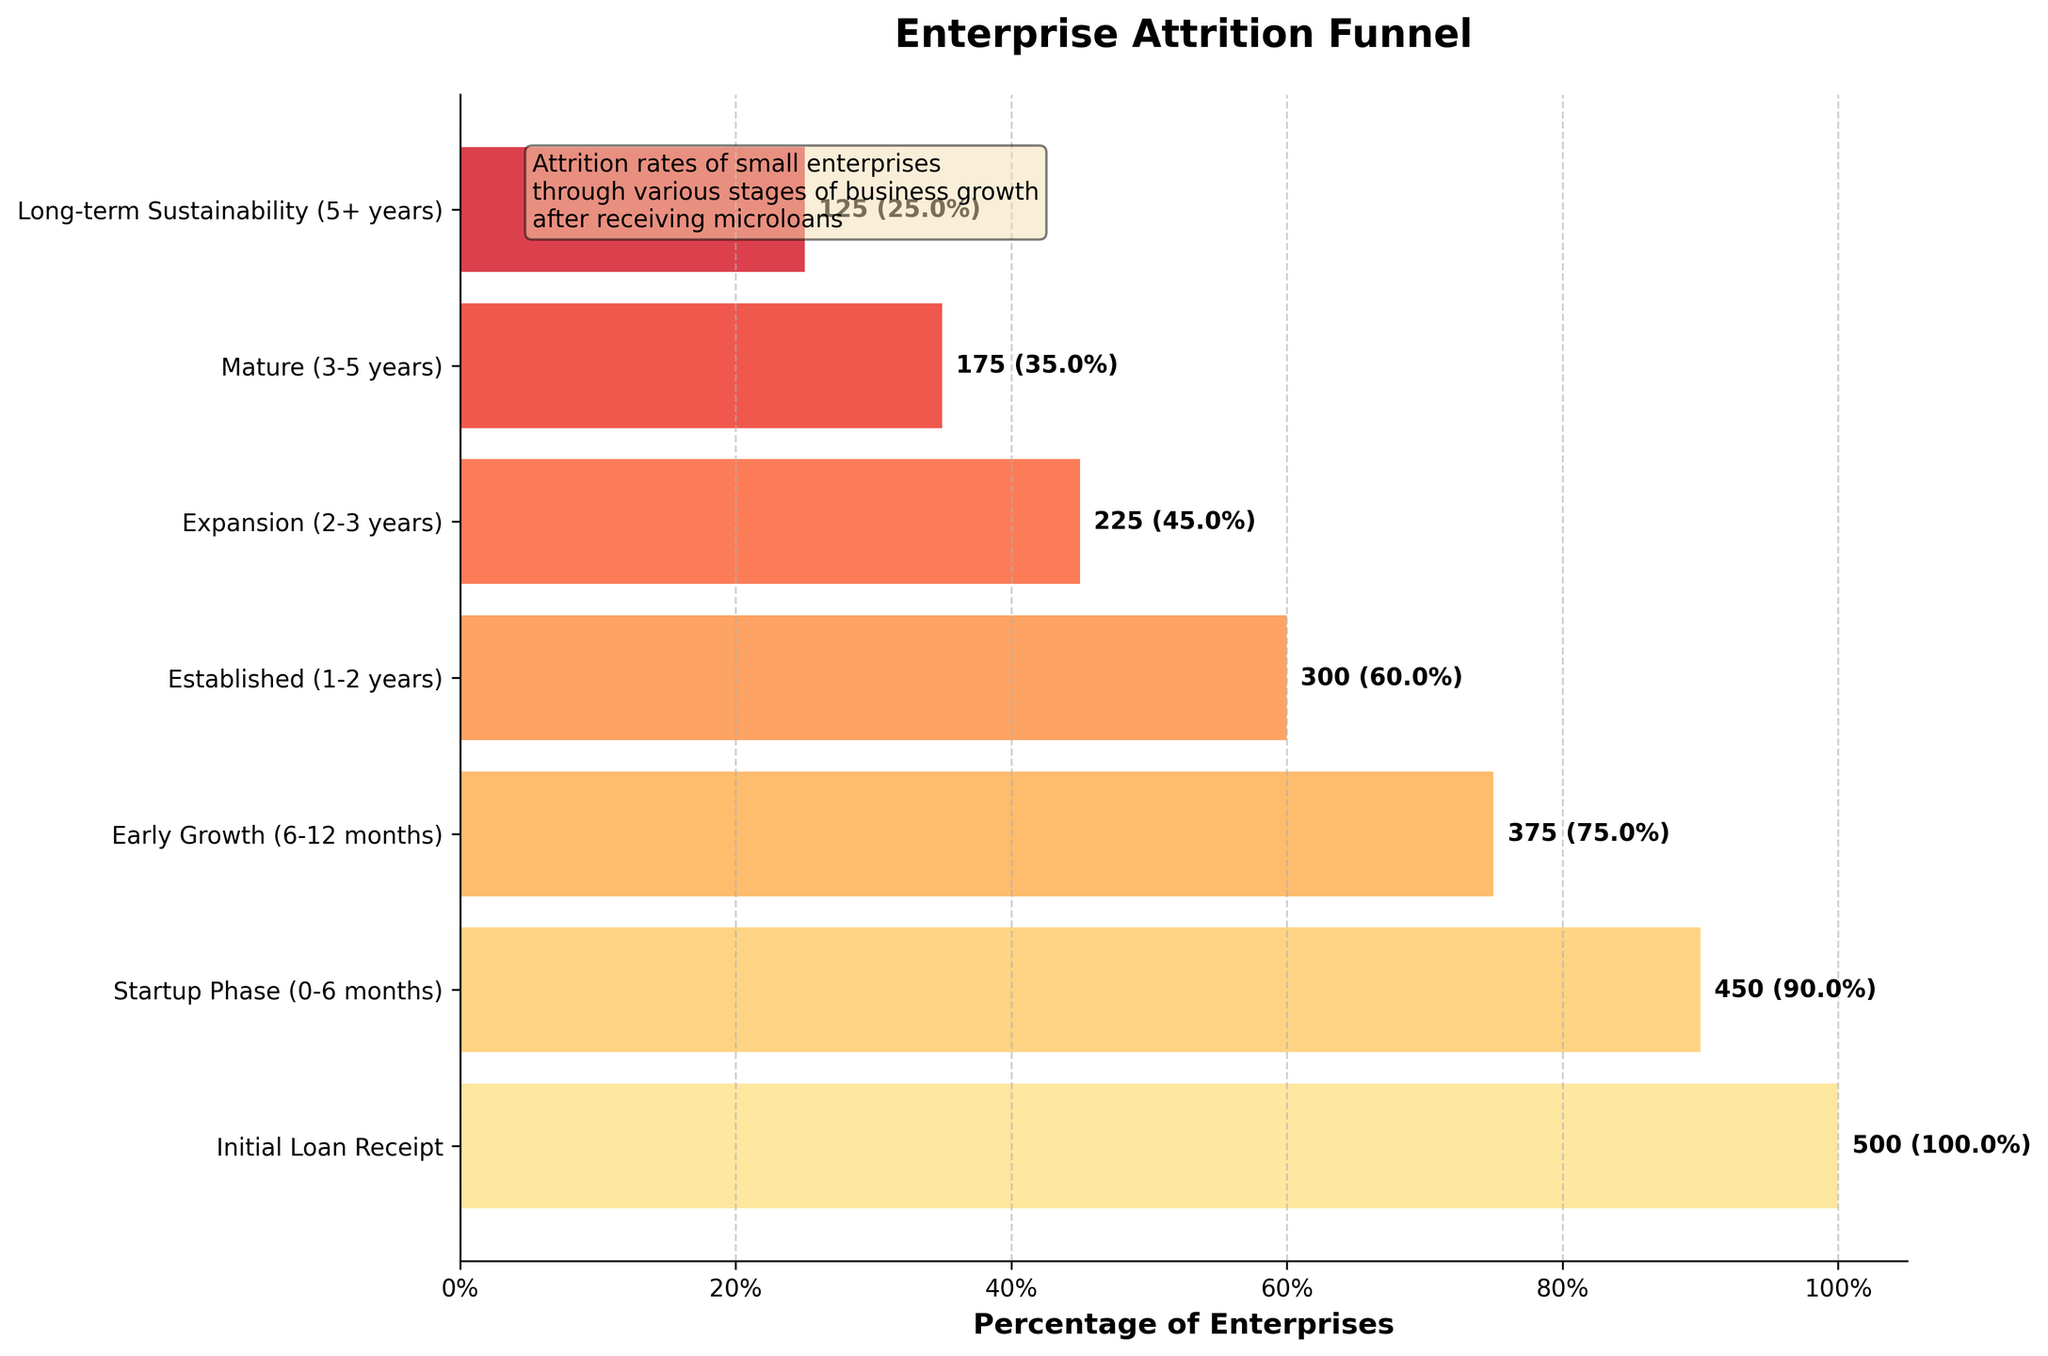What's the title of the figure? The title is usually clearly visible at the top of the figure. In this case, it's noted as "Enterprise Attrition Funnel."
Answer: Enterprise Attrition Funnel What is the percentage of enterprises that reach the Established stage (1-2 years)? From the figure, find the "Established (1-2 years)" stage and then look at the percentage along the corresponding bar. This value should be labeled directly on the plot.
Answer: 60.0% How many enterprises move from the Startup Phase (0-6 months) to the Early Growth (6-12 months) phase? Look at the number of enterprises in the Startup Phase, which is 450. Then, find the number in the Early Growth phase, which is 375. Subtract the latter from the former: 450 - 375 = 75.
Answer: 75 Which stage has the highest attrition rate? Calculate the difference in the number of enterprises between each consecutive stage to find the stage with the largest drop. Comparing the differences: Initial to Startup = 50, Startup to Early Growth = 75, Early Growth to Established = 75, Established to Expansion = 75, Expansion to Mature = 50, Mature to Long-term Sustainability = 50. The equal attrition of 75 occurs three times. Any of the three transitions of 75 would be correct.
Answer: Early Growth, Established, Expansion What percentage of enterprises reach Long-term Sustainability (5+ years)? From the figure, find the "Long-term Sustainability (5+ years)" stage and then look at the percentage along the corresponding bar. This value should be labeled directly on the plot.
Answer: 25.0% Compare the number of enterprises in the Expansion (2-3 years) stage with the Mature (3-5 years) stage. Which one has fewer enterprises? Look at the number of enterprises in each stage. The Expansion stage has 225 enterprises, while the Mature stage has 175 enterprises. Compare these values to see which is fewer.
Answer: Mature stage By what percentage does the number of enterprises decrease from the Early Growth to the Established stage? Calculate the number of enterprises at the Early Growth stage (375) and the Established stage (300). The decrease is 375 - 300 = 75. Calculate the percentage decrease: (75/375) * 100 ≈ 20.0%.
Answer: 20.0% What is the range of the percentages of enterprises across all stages? Determine the minimum and maximum percentages from the figure's bars: the highest percentage is 100% (Initial Loan Receipt) and the lowest is 25% (Long-term Sustainability). Calculate the range: 100% - 25% = 75%.
Answer: 75% What is the attrition rate from the Initial Loan Receipt stage to the Startup Phase (0-6 months)? Find the number of enterprises in the Initial stage (500) and the Startup Phase (450). The attrition rate is calculated as follows: (500 - 450) / 500 * 100 ≈ 10.0%.
Answer: 10.0% Which stage shows a 30% reduction in the number of enterprises from the previous stage? Look at the percentages for each stage. A 30% reduction would occur if the percentage for a stage is 70% of the previous stage. From the Initial Loan Receipt (100%) to the Established stage (60%), and none of the others match.
Answer: Established stage 